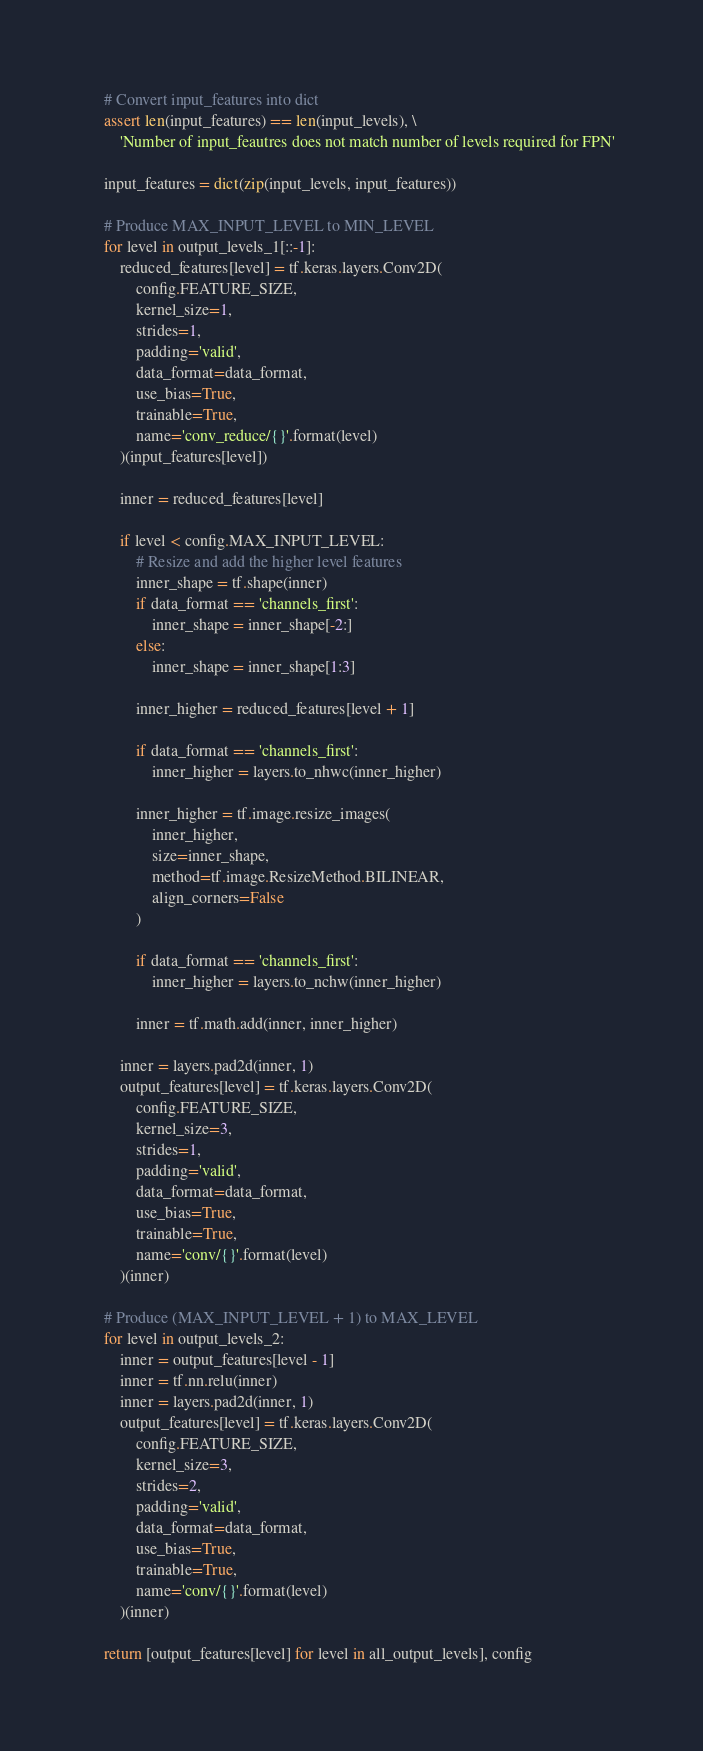Convert code to text. <code><loc_0><loc_0><loc_500><loc_500><_Python_>    # Convert input_features into dict
    assert len(input_features) == len(input_levels), \
        'Number of input_feautres does not match number of levels required for FPN'

    input_features = dict(zip(input_levels, input_features))

    # Produce MAX_INPUT_LEVEL to MIN_LEVEL
    for level in output_levels_1[::-1]:
        reduced_features[level] = tf.keras.layers.Conv2D(
            config.FEATURE_SIZE,
            kernel_size=1,
            strides=1,
            padding='valid',
            data_format=data_format,
            use_bias=True,
            trainable=True,
            name='conv_reduce/{}'.format(level)
        )(input_features[level])

        inner = reduced_features[level]

        if level < config.MAX_INPUT_LEVEL:
            # Resize and add the higher level features
            inner_shape = tf.shape(inner)
            if data_format == 'channels_first':
                inner_shape = inner_shape[-2:]
            else:
                inner_shape = inner_shape[1:3]

            inner_higher = reduced_features[level + 1]

            if data_format == 'channels_first':
                inner_higher = layers.to_nhwc(inner_higher)

            inner_higher = tf.image.resize_images(
                inner_higher,
                size=inner_shape,
                method=tf.image.ResizeMethod.BILINEAR,
                align_corners=False
            )

            if data_format == 'channels_first':
                inner_higher = layers.to_nchw(inner_higher)

            inner = tf.math.add(inner, inner_higher)

        inner = layers.pad2d(inner, 1)
        output_features[level] = tf.keras.layers.Conv2D(
            config.FEATURE_SIZE,
            kernel_size=3,
            strides=1,
            padding='valid',
            data_format=data_format,
            use_bias=True,
            trainable=True,
            name='conv/{}'.format(level)
        )(inner)

    # Produce (MAX_INPUT_LEVEL + 1) to MAX_LEVEL
    for level in output_levels_2:
        inner = output_features[level - 1]
        inner = tf.nn.relu(inner)
        inner = layers.pad2d(inner, 1)
        output_features[level] = tf.keras.layers.Conv2D(
            config.FEATURE_SIZE,
            kernel_size=3,
            strides=2,
            padding='valid',
            data_format=data_format,
            use_bias=True,
            trainable=True,
            name='conv/{}'.format(level)
        )(inner)

    return [output_features[level] for level in all_output_levels], config
</code> 